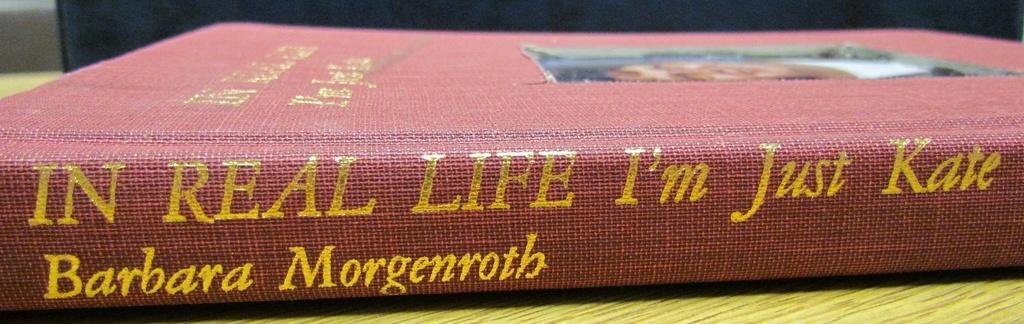What is the main object in the image? There is a book with text in the image. Where is the book located? The book is on an object. What can be seen behind the book? There is a background visible in the image. What type of pipe is being played in the background of the image? There is no pipe or any musical instrument visible in the image; it only features a book with text and a background. 